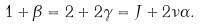<formula> <loc_0><loc_0><loc_500><loc_500>1 + \beta = 2 + 2 \gamma = J + 2 \nu \alpha .</formula> 